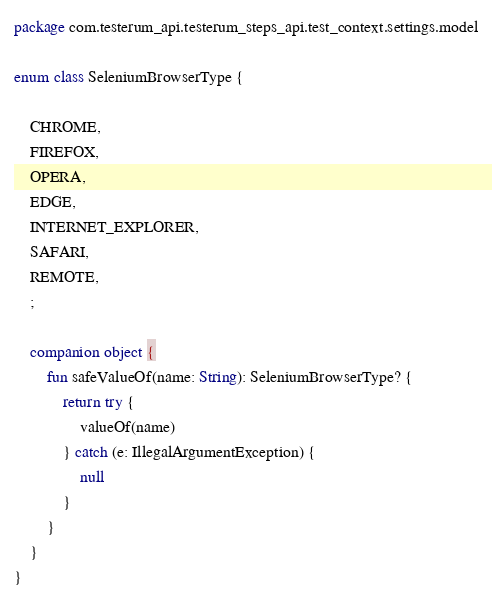<code> <loc_0><loc_0><loc_500><loc_500><_Kotlin_>package com.testerum_api.testerum_steps_api.test_context.settings.model

enum class SeleniumBrowserType {

    CHROME,
    FIREFOX,
    OPERA,
    EDGE,
    INTERNET_EXPLORER,
    SAFARI,
    REMOTE,
    ;

    companion object {
        fun safeValueOf(name: String): SeleniumBrowserType? {
            return try {
                valueOf(name)
            } catch (e: IllegalArgumentException) {
                null
            }
        }
    }
}
</code> 